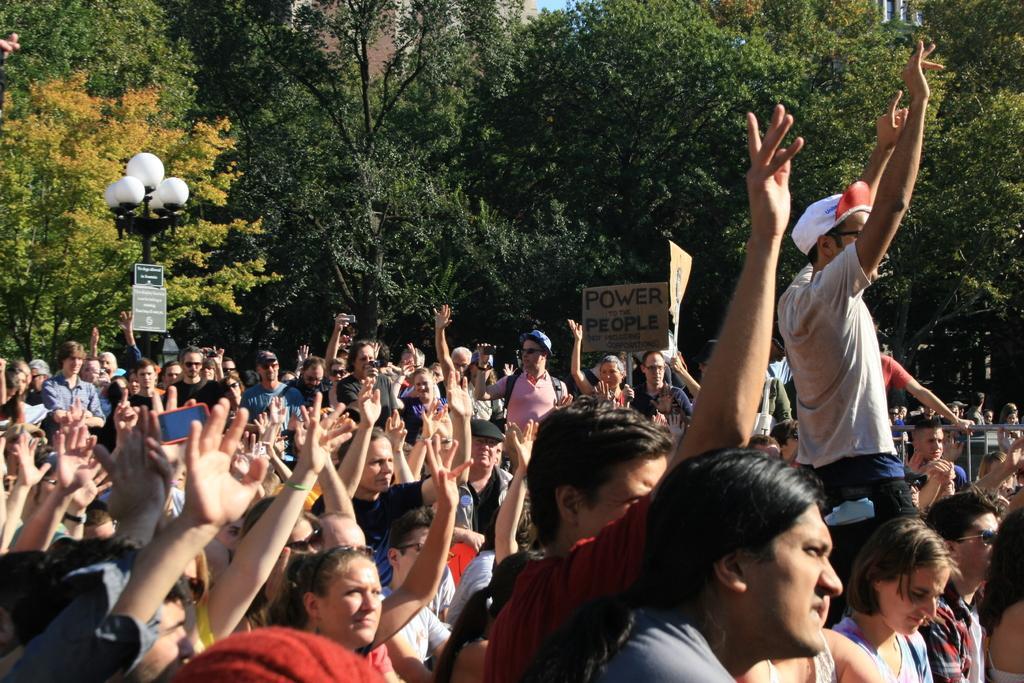Can you describe this image briefly? In this image I can see number of persons are standing and I can see few of them are holding boards in their hands. I can see few trees which are green, yellow and orange in color, few buildings, a black colored pole with lights on them and in the background I can see few buildings and the sky. 